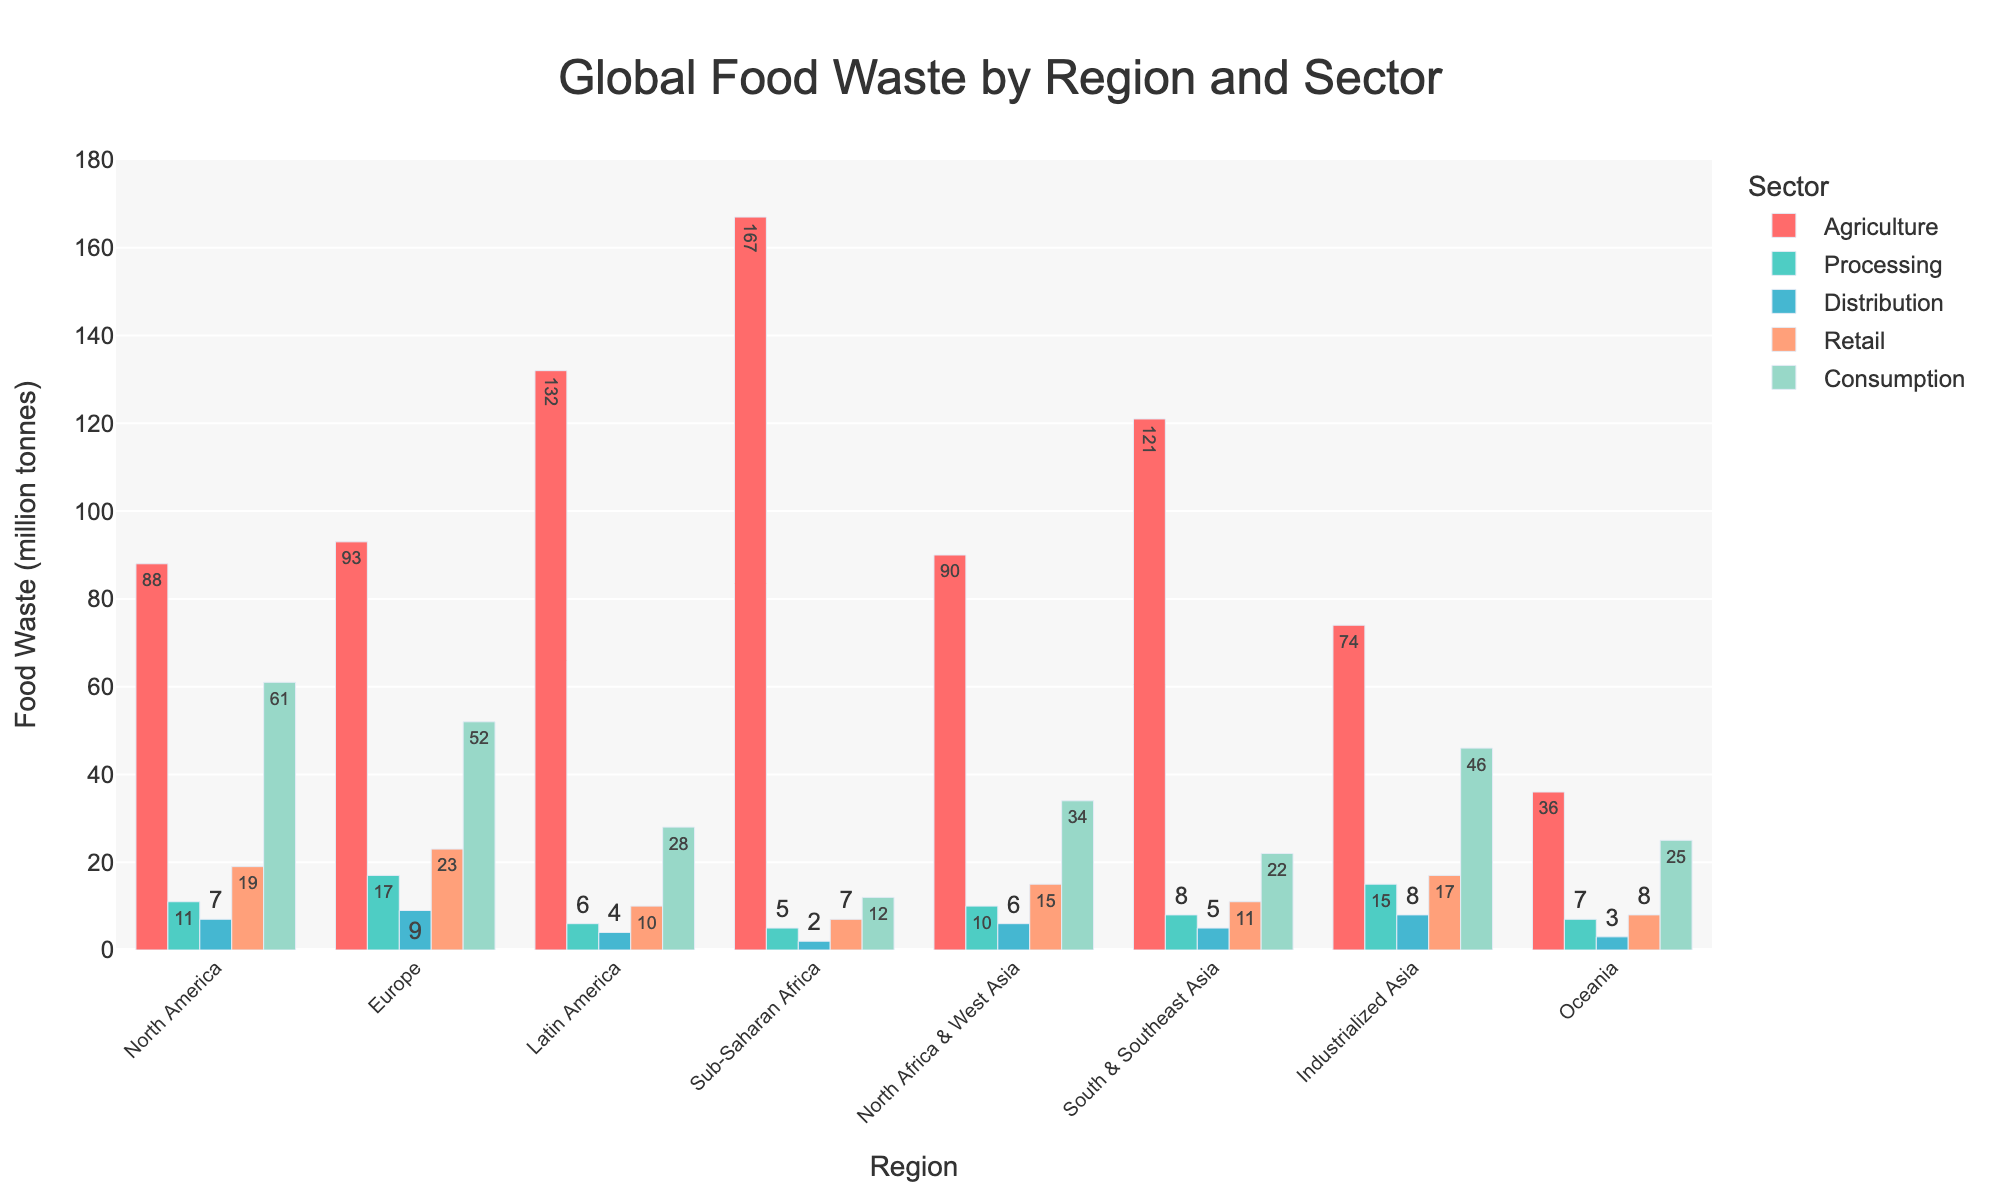What is the region with the highest food waste in the Agriculture sector? The bar representing Sub-Saharan Africa in the Agriculture sector is the tallest, indicating the highest food waste in this sector.
Answer: Sub-Saharan Africa Which region has the lowest food waste in the Retail sector, and what is the amount? By comparing the bars for the Retail sector across all regions, the Oceania region has the shortest bar, indicating the lowest value.
Answer: Oceania, 8 million tonnes How does the food waste in North America's Consumption sector compare to that of Europe? The bar for North America in the Consumption sector is taller than that of Europe, indicating North America has higher food waste.
Answer: North America's is higher Which sector contributes the most to food waste in European regions, and what is the amount? The tallest bar within the Europe region is in the Agriculture sector, indicating that Agriculture contributes the most to food waste in Europe.
Answer: Agriculture, 93 million tonnes Which region has a closer amount of food waste in the Agriculture and Processing sectors? By visually comparing the heights of the bars in the Agriculture and Processing sectors, North Africa & West Asia's bars are closely matched.
Answer: North Africa & West Asia What is the total food waste in the Retail sector for all regions combined? Add the values for the Retail sector from all regions: 19 (North America) + 23 (Europe) + 10 (Latin America) + 7 (Sub-Saharan Africa) + 15 (North Africa & West Asia) + 11 (South & Southeast Asia) + 17 (Industrialized Asia) + 8 (Oceania) = 110.
Answer: 110 million tonnes Between Industrialized Asia and North Africa & West Asia, which region has higher overall food waste? Add the food waste values from all sectors for both regions: Industrialized Asia (74 + 15 + 8 + 17 + 46 = 160), North Africa & West Asia (90 + 10 + 6 + 15 + 34 = 155). Compare the totals.
Answer: Industrialized Asia Is the food waste in the Distribution sector generally higher in regions from the Global North compared to the Global South? Compare the heights of the Distribution bars for regions typically considered in the Global North (North America, Europe, Industrialized Asia) to those in the Global South (Latin America, Sub-Saharan Africa, South & Southeast Asia, North Africa & West Asia). The bars are relatively higher in the North.
Answer: Yes If we sum up the food waste for Latin America, South & Southeast Asia, and Oceania in the Consumption sector, what is the total amount? Add the values for the Consumption sector in these regions: 28 (Latin America) + 22 (South & Southeast Asia) + 25 (Oceania) = 75.
Answer: 75 million tonnes 